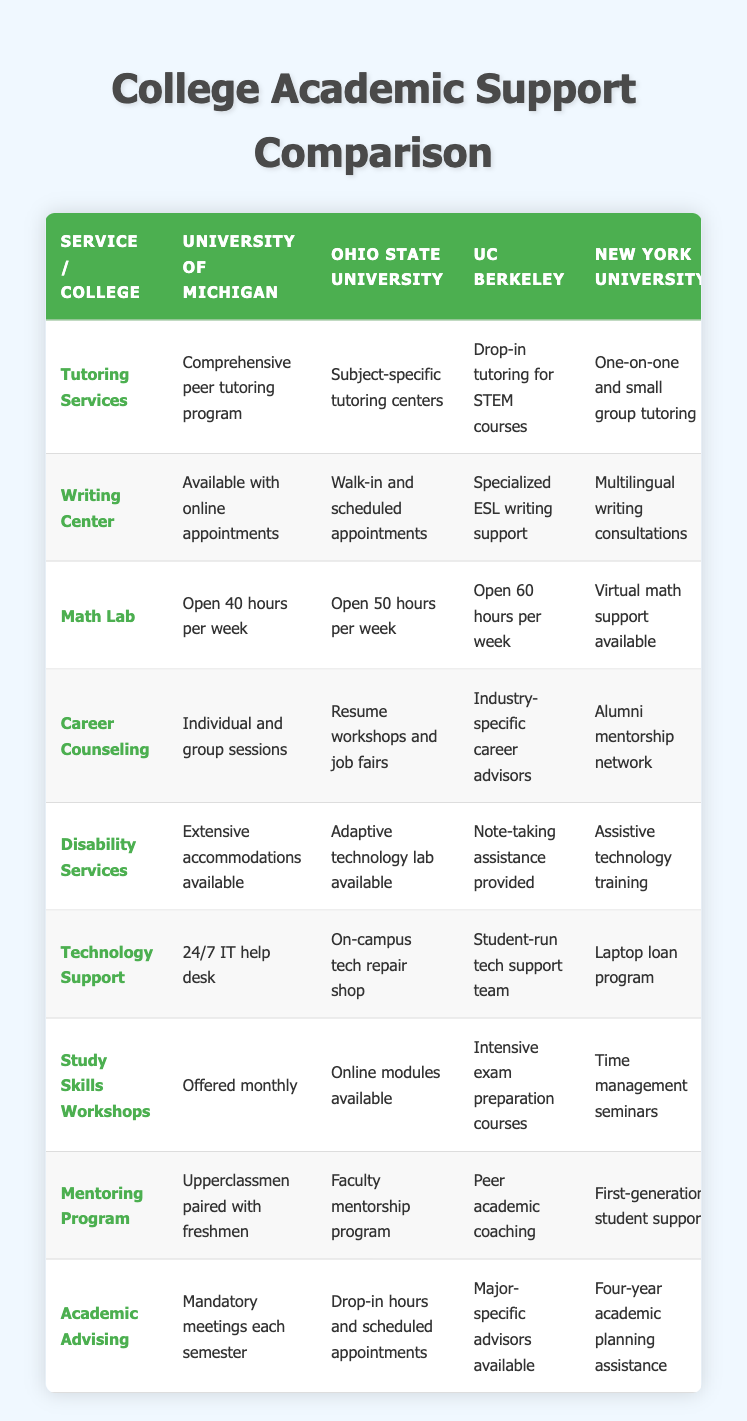What tutoring services does UC Berkeley offer? The table shows that UC Berkeley provides "Drop-in tutoring for STEM courses" as its tutoring service.
Answer: Drop-in tutoring for STEM courses Which university has the longest math lab hours? By comparing the Math Lab hours listed for each university, UC Berkeley has the longest hours at 60 hours per week, more than the others.
Answer: UC Berkeley Does New York University offer career counseling services? The table indicates that New York University does offer career counseling services, specifically mentioning "Alumni mentorship network."
Answer: Yes What type of writing center support does Ohio State University provide? According to the table, Ohio State University has a writing center that provides both "Walk-in and scheduled appointments."
Answer: Walk-in and scheduled appointments Which two universities have specific programs for mentoring? The table lists the mentoring programs for University of Michigan (Upperclassmen paired with freshmen) and Ohio State University (Faculty mentorship program). Therefore, these two universities have specific mentoring programs.
Answer: University of Michigan and Ohio State University How many hours is the math lab at the University of Texas at Austin open? The table states that the math lab at the University of Texas at Austin is focused on Calculus and statistics but does not explicitly list the hours. However, since the hours are not shown, we cannot provide a specific answer based on the table.
Answer: Not specified Which college offers intensive exam preparation courses? The table shows that UC Berkeley provides "Intensive exam preparation courses" as part of its study skills workshops.
Answer: UC Berkeley What is the difference in accessibility services between University of Michigan and University of Texas at Austin? University of Michigan provides "Extensive accommodations available," while University of Texas at Austin offers "Testing accommodations coordinated." So, both have services but of different scopes and focus.
Answer: Different scopes Does every college have a technology support service? Yes, every college listed has a technology support service available, indicating that it is a common support service among them.
Answer: Yes 